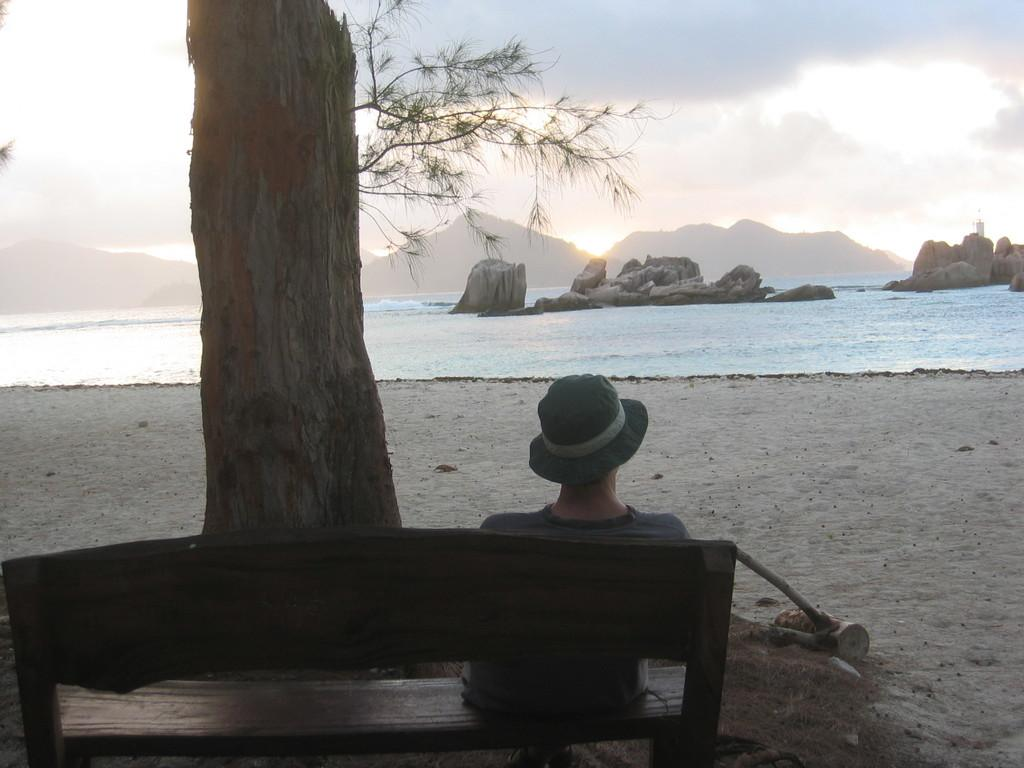What is the person in the image doing? The person is sitting on a bench in the image. What is located in front of the person? There is a tree in front of the person. What can be seen in the background of the image? There is an ocean visible in the image. What type of note is the person holding in the image? There is no note present in the image; the person is simply sitting on a bench. 